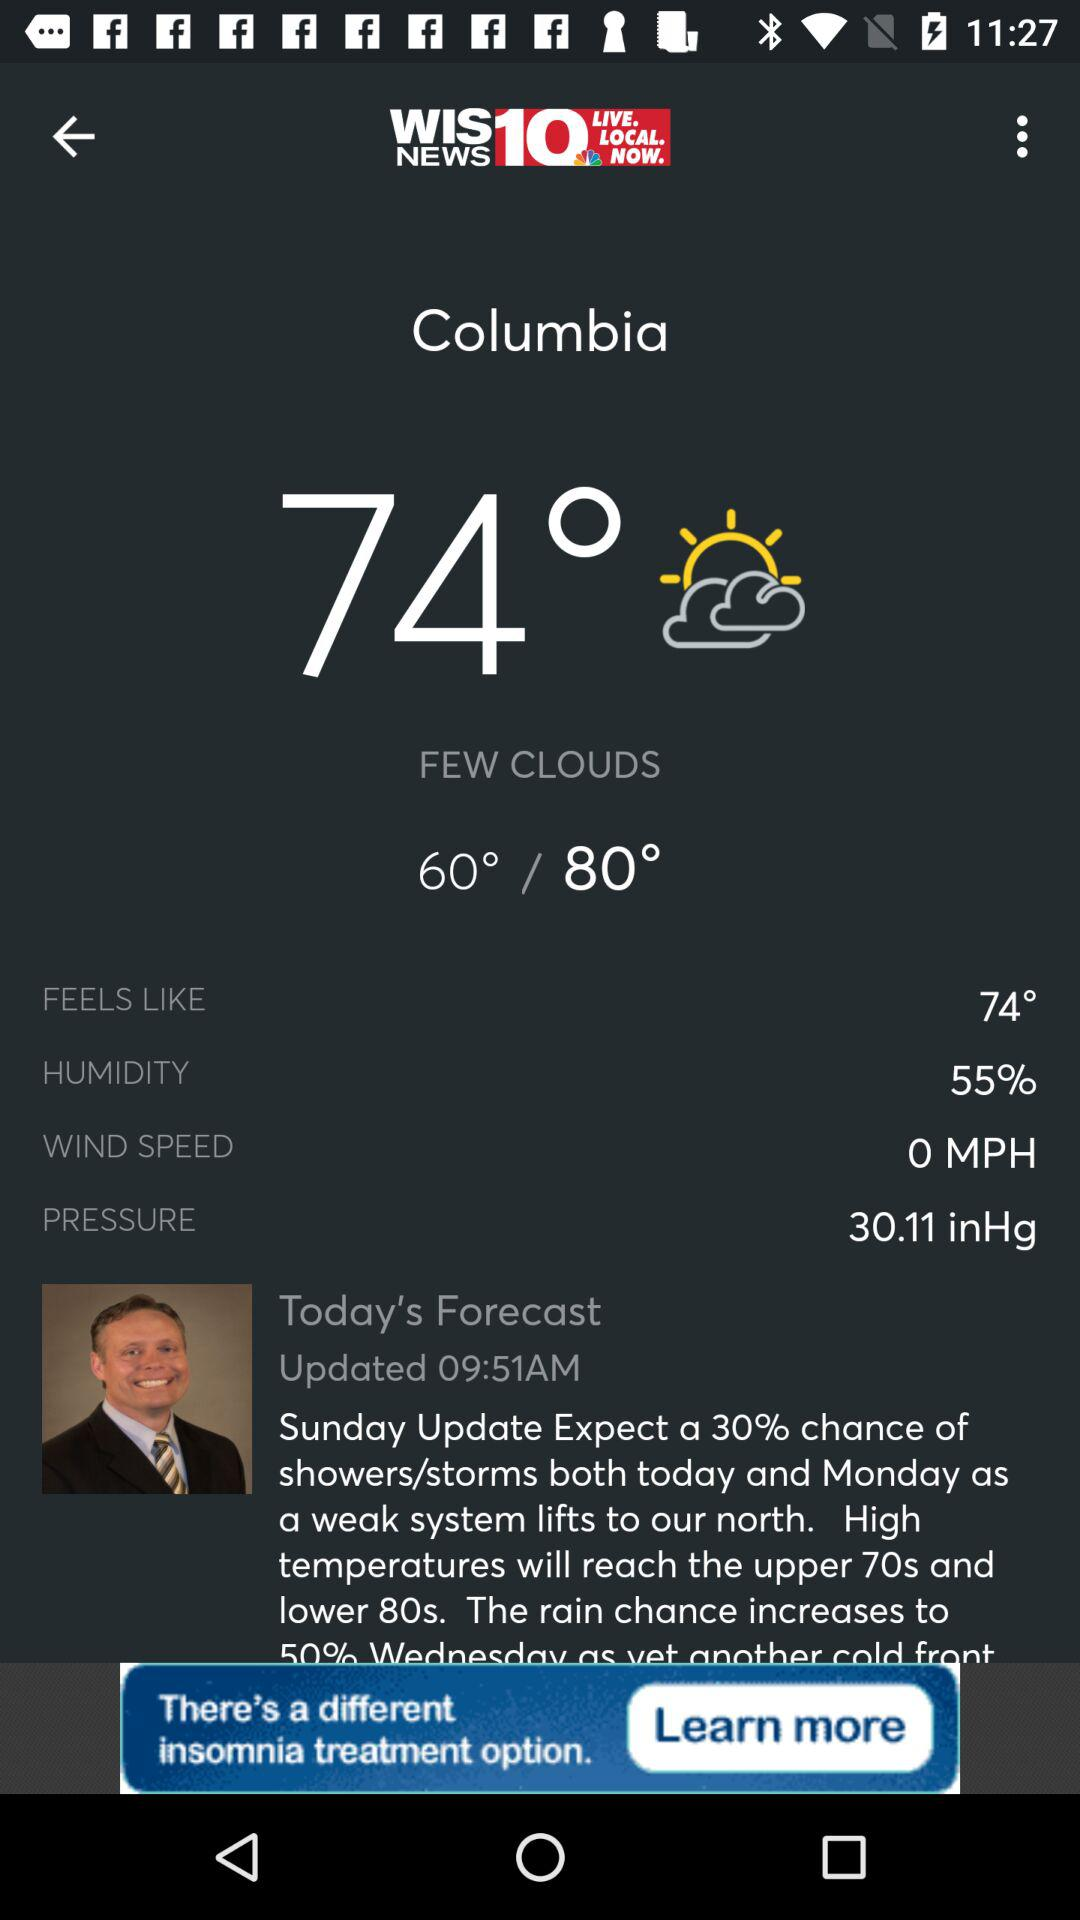What is the difference in temperature between the high and low today?
Answer the question using a single word or phrase. 20° 